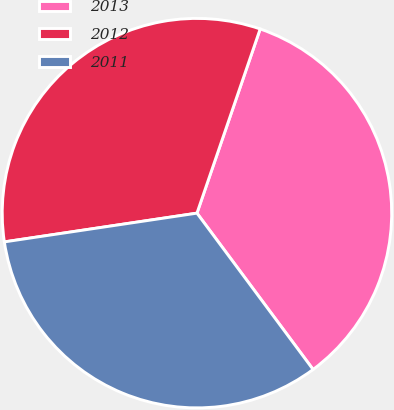Convert chart. <chart><loc_0><loc_0><loc_500><loc_500><pie_chart><fcel>2013<fcel>2012<fcel>2011<nl><fcel>34.57%<fcel>32.62%<fcel>32.81%<nl></chart> 